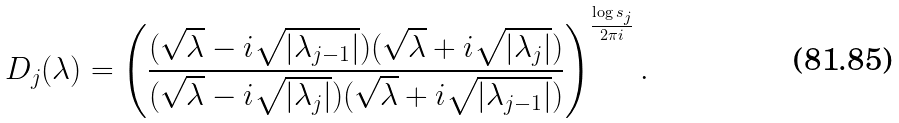Convert formula to latex. <formula><loc_0><loc_0><loc_500><loc_500>D _ { j } ( \lambda ) = \left ( \frac { ( \sqrt { \lambda } - i \sqrt { | \lambda _ { j - 1 } | } ) ( \sqrt { \lambda } + i \sqrt { | \lambda _ { j } | } ) } { ( \sqrt { \lambda } - i \sqrt { | \lambda _ { j } | } ) ( \sqrt { \lambda } + i \sqrt { | \lambda _ { j - 1 } | } ) } \right ) ^ { \frac { \log s _ { j } } { 2 \pi i } } .</formula> 